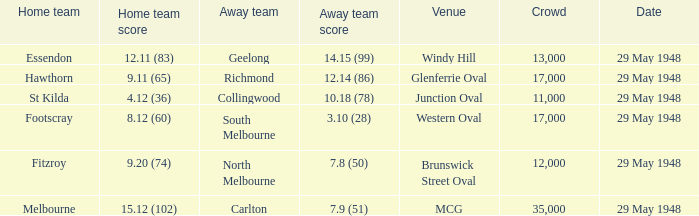During melbourne's home game, who was the away team? Carlton. I'm looking to parse the entire table for insights. Could you assist me with that? {'header': ['Home team', 'Home team score', 'Away team', 'Away team score', 'Venue', 'Crowd', 'Date'], 'rows': [['Essendon', '12.11 (83)', 'Geelong', '14.15 (99)', 'Windy Hill', '13,000', '29 May 1948'], ['Hawthorn', '9.11 (65)', 'Richmond', '12.14 (86)', 'Glenferrie Oval', '17,000', '29 May 1948'], ['St Kilda', '4.12 (36)', 'Collingwood', '10.18 (78)', 'Junction Oval', '11,000', '29 May 1948'], ['Footscray', '8.12 (60)', 'South Melbourne', '3.10 (28)', 'Western Oval', '17,000', '29 May 1948'], ['Fitzroy', '9.20 (74)', 'North Melbourne', '7.8 (50)', 'Brunswick Street Oval', '12,000', '29 May 1948'], ['Melbourne', '15.12 (102)', 'Carlton', '7.9 (51)', 'MCG', '35,000', '29 May 1948']]} 